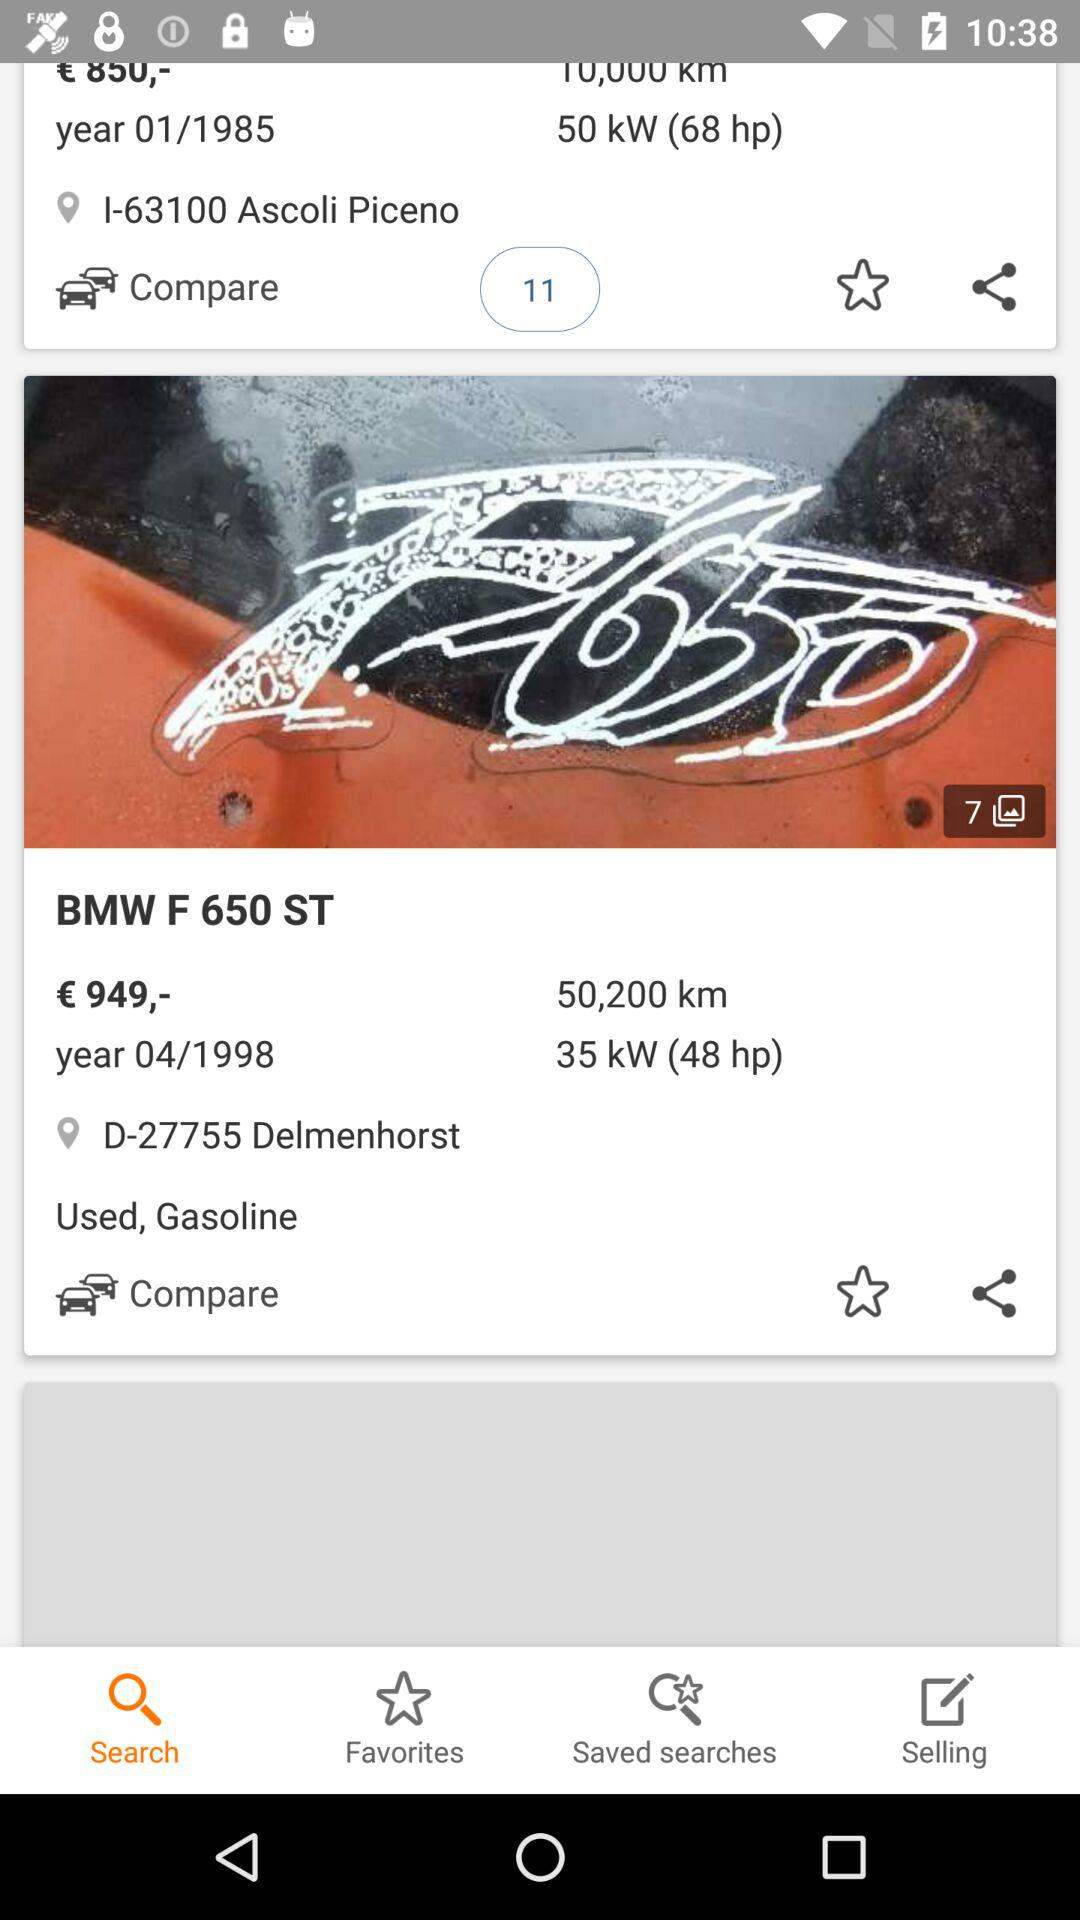Which car has a higher price, BMW F 650 ST or Fiat 126?
Answer the question using a single word or phrase. BMW F 650 ST 